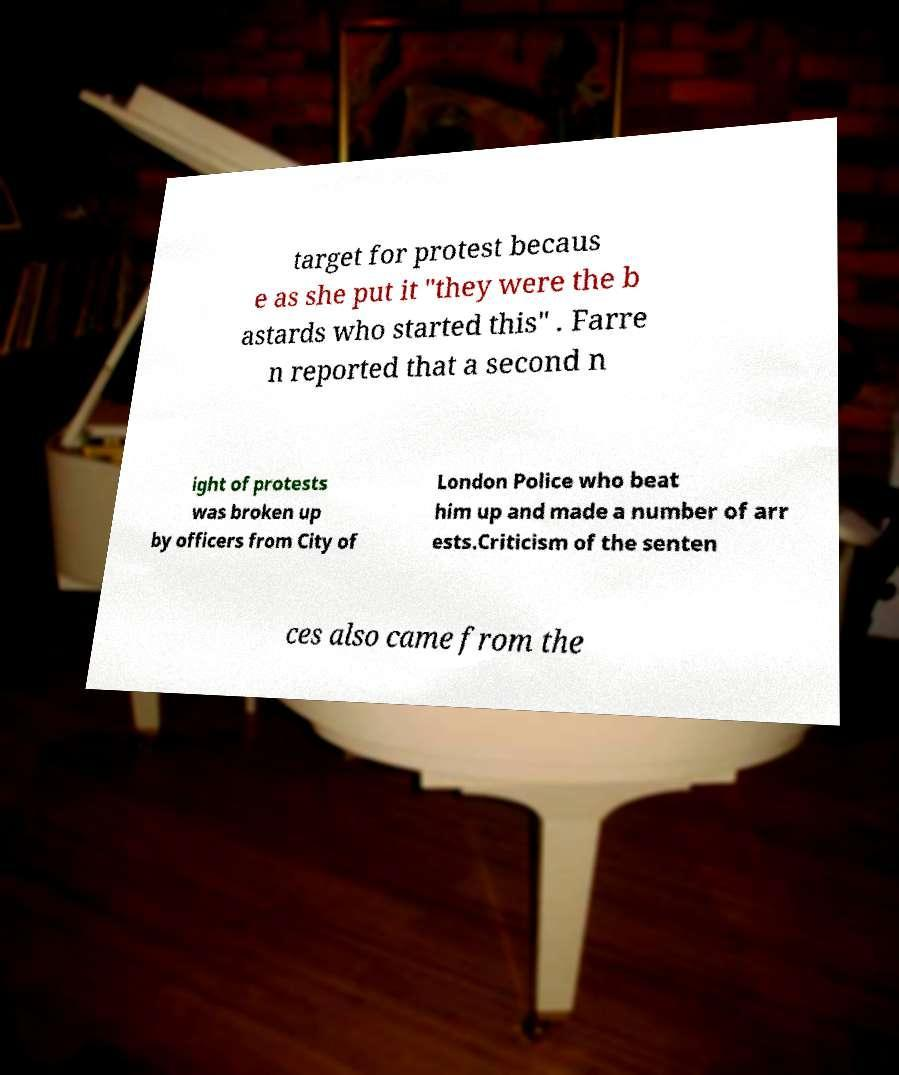There's text embedded in this image that I need extracted. Can you transcribe it verbatim? target for protest becaus e as she put it "they were the b astards who started this" . Farre n reported that a second n ight of protests was broken up by officers from City of London Police who beat him up and made a number of arr ests.Criticism of the senten ces also came from the 